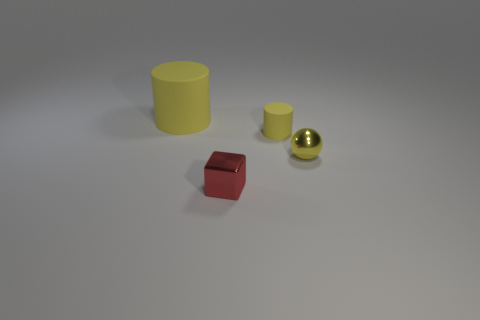Add 1 large cylinders. How many objects exist? 5 Add 4 big green cubes. How many big green cubes exist? 4 Subtract 0 brown cylinders. How many objects are left? 4 Subtract all red blocks. Subtract all big cylinders. How many objects are left? 2 Add 3 spheres. How many spheres are left? 4 